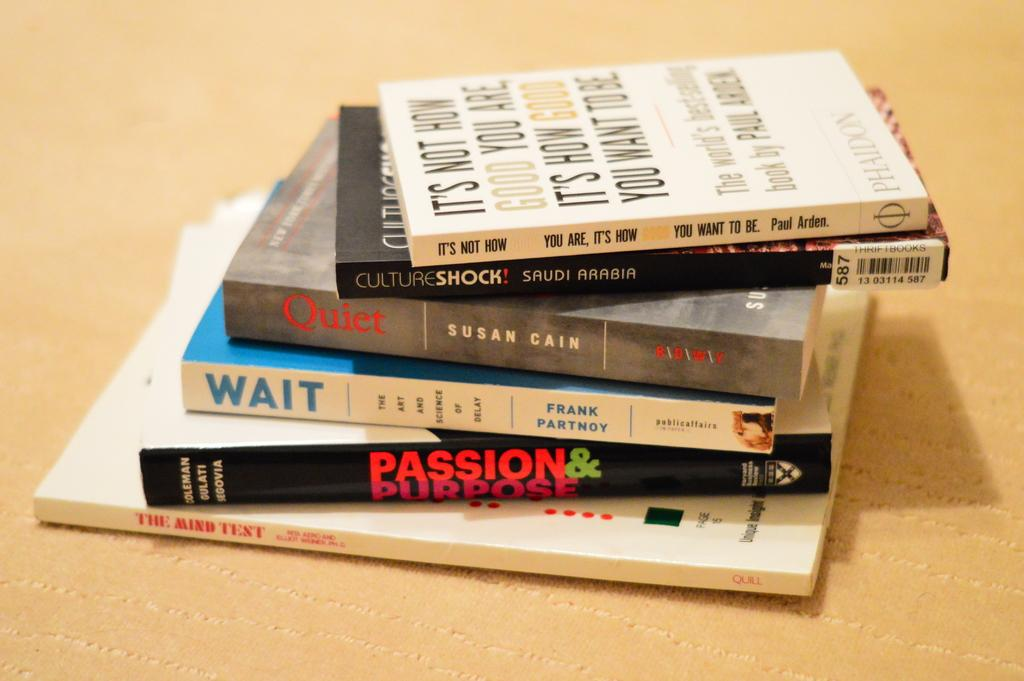<image>
Describe the image concisely. stacks of books like Passion Purpose and Quiet 